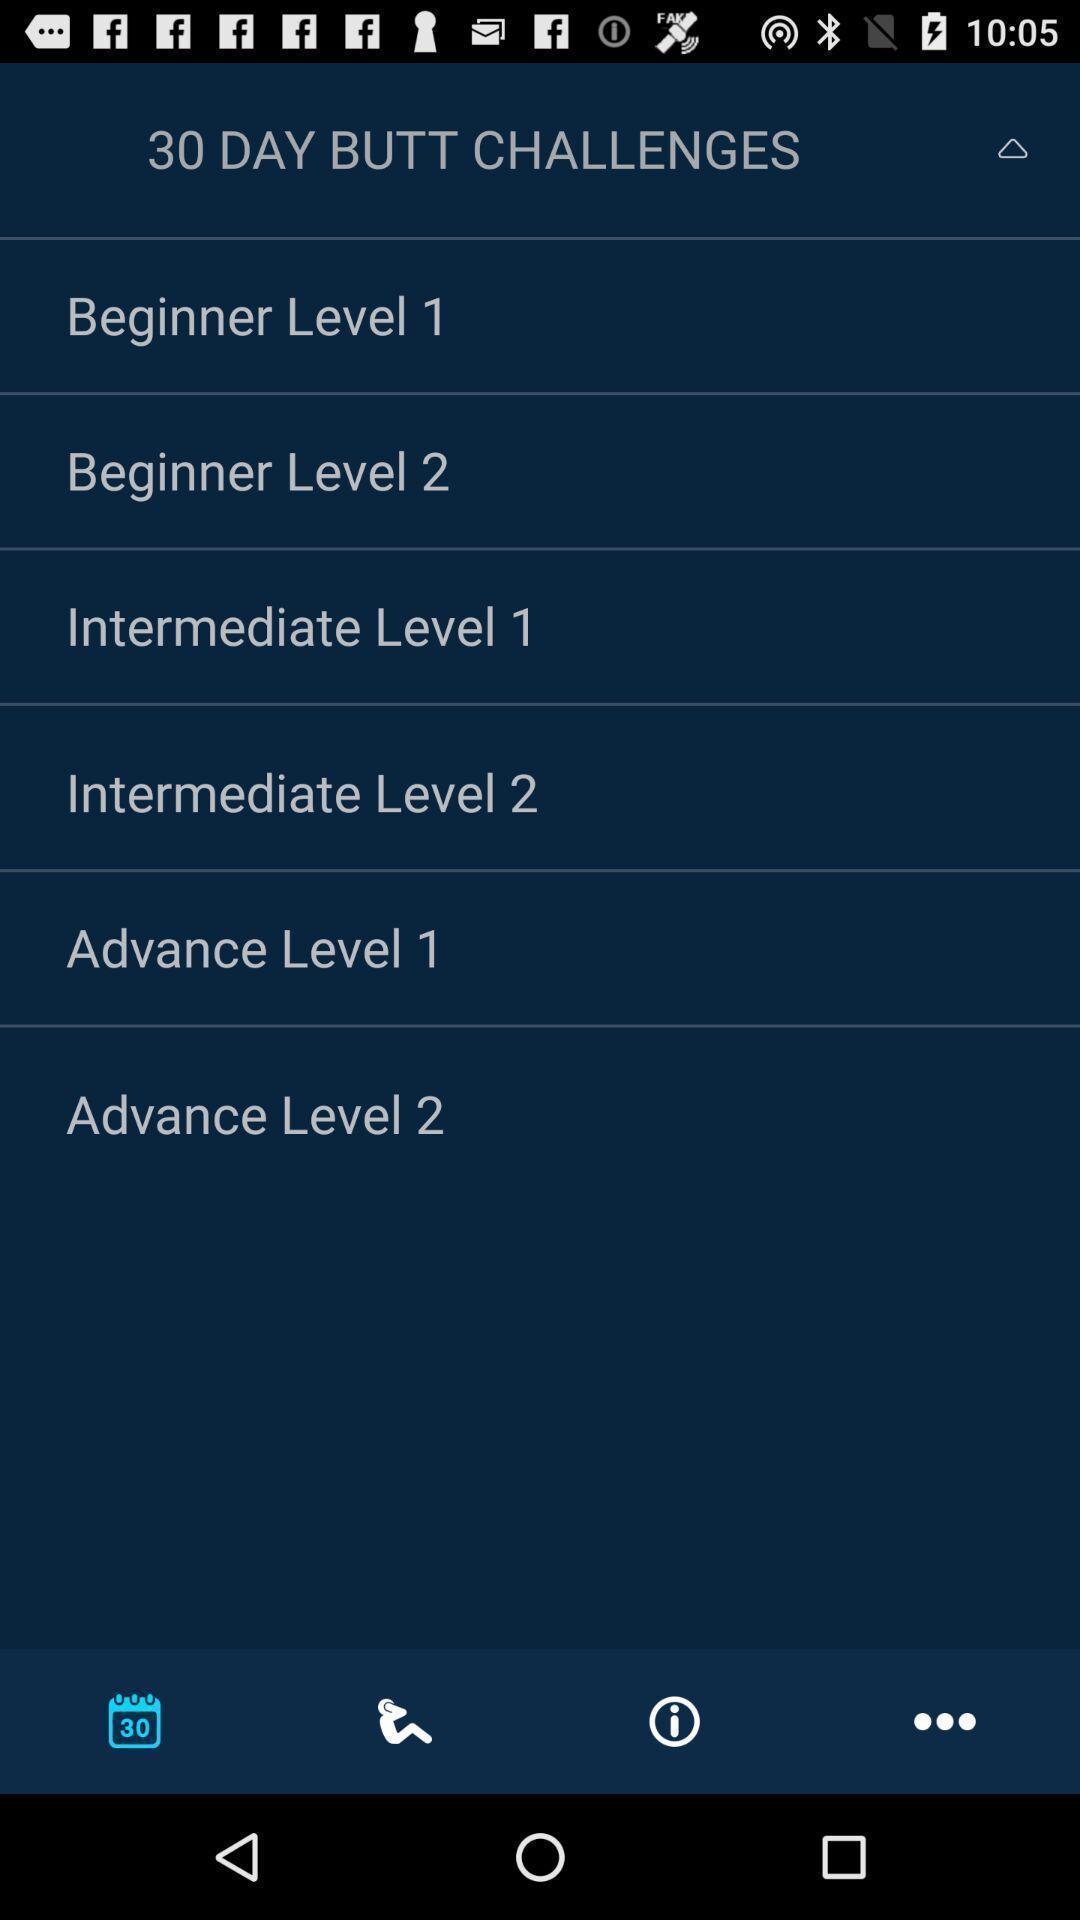Provide a description of this screenshot. Screen shows challenges levels. 